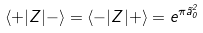<formula> <loc_0><loc_0><loc_500><loc_500>\langle + | Z | - \rangle = \langle - | Z | + \rangle = e ^ { \pi \tilde { a } _ { 0 } ^ { 2 } }</formula> 